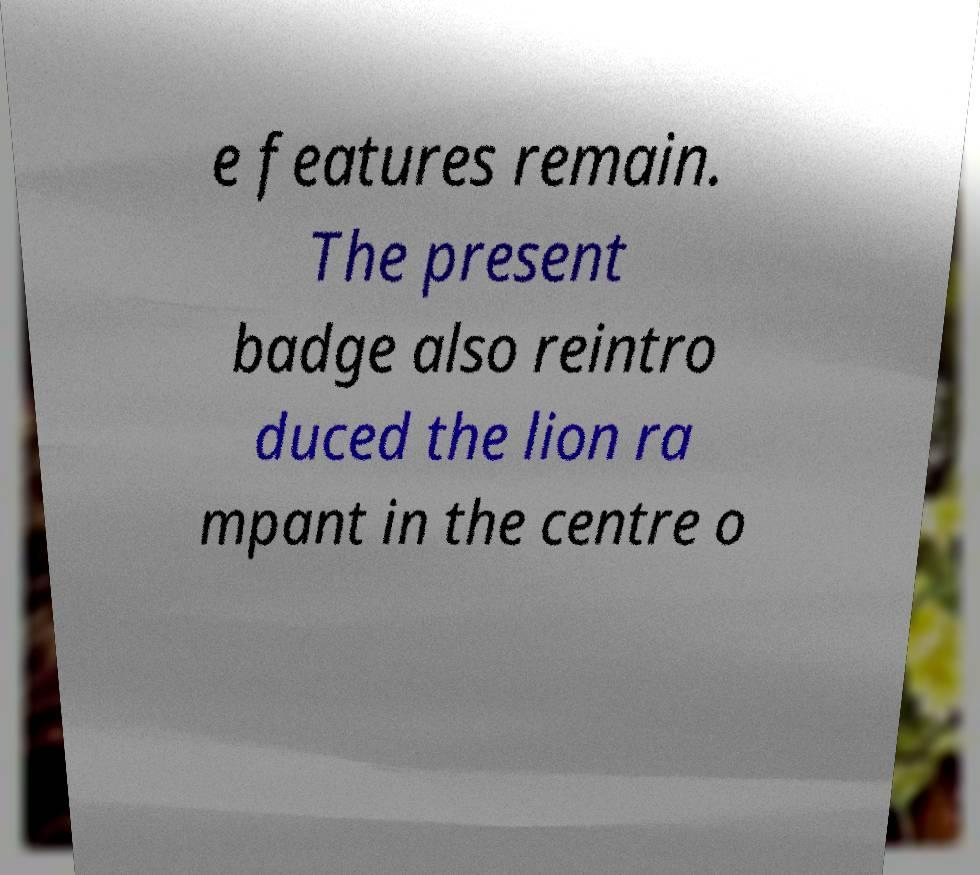Could you assist in decoding the text presented in this image and type it out clearly? e features remain. The present badge also reintro duced the lion ra mpant in the centre o 